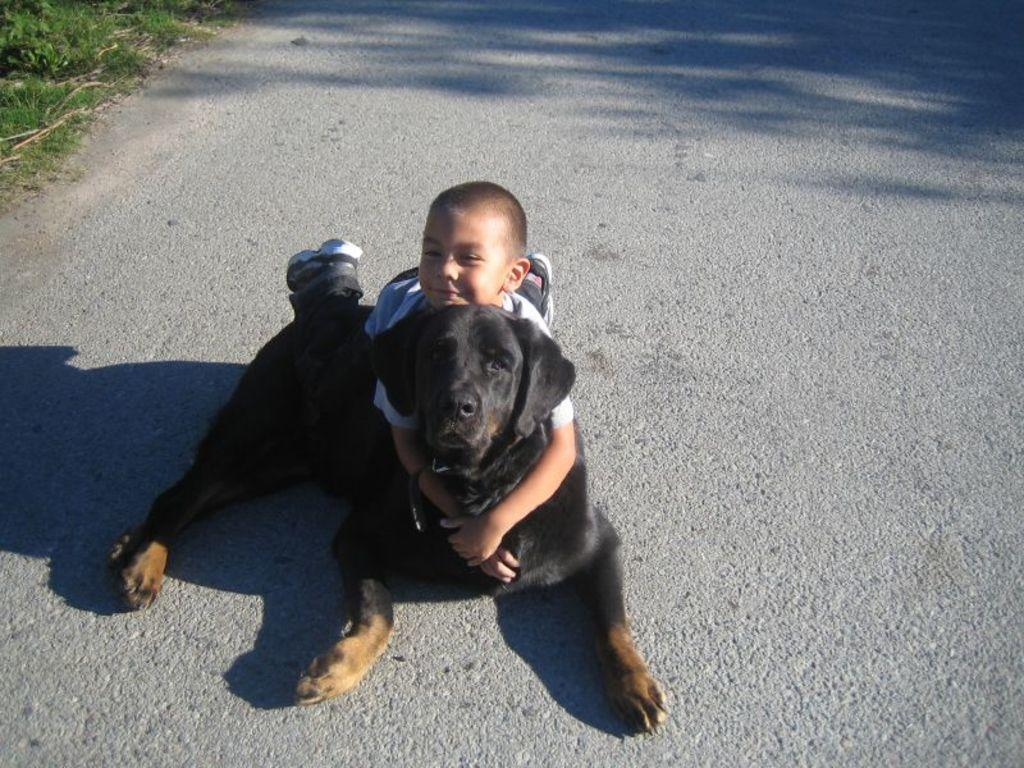What is the main subject of the image? The main subject of the image is a small kid. What is the kid holding in the image? The kid is holding a black dog. Where are the kid and the dog located in the image? Both the kid and the dog are resting on the floor. What can be seen in the top left corner of the image? There are small trees in the top left corner of the image. What type of sail can be seen in the image? There is no sail present in the image. How does the earthquake affect the kid and the dog in the image? There is no earthquake depicted in the image, so its effects cannot be determined. 